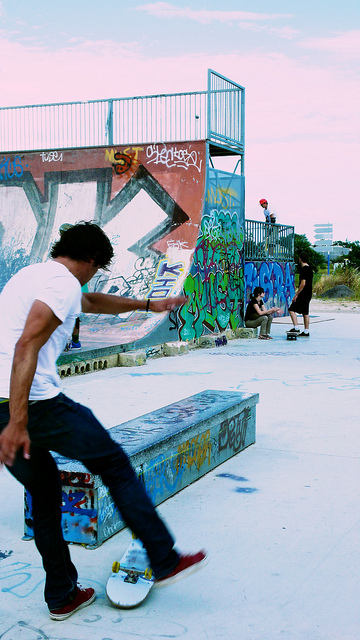<image>Which foot does the man have on his skateboard? I am not sure which foot the man has on his skateboard. It can be his right foot or none. Which foot does the man have on his skateboard? It is ambiguous which foot the man has on his skateboard. It can be seen both left and right. 